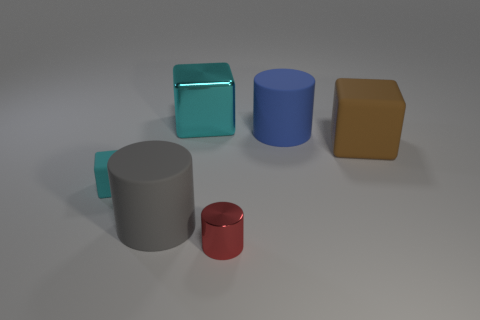Add 1 small brown shiny cylinders. How many objects exist? 7 Add 6 tiny red metal objects. How many tiny red metal objects exist? 7 Subtract 0 gray spheres. How many objects are left? 6 Subtract all gray rubber blocks. Subtract all large cyan metal cubes. How many objects are left? 5 Add 3 big gray cylinders. How many big gray cylinders are left? 4 